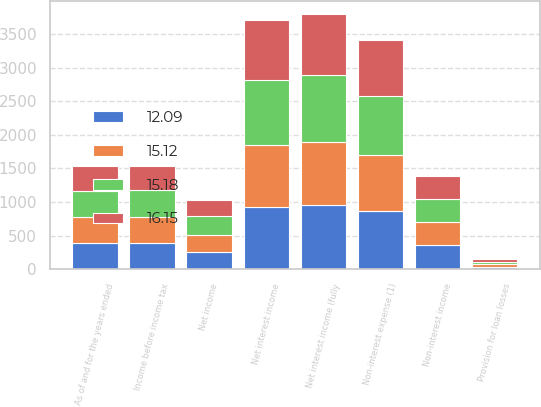Convert chart. <chart><loc_0><loc_0><loc_500><loc_500><stacked_bar_chart><ecel><fcel>As of and for the years ended<fcel>Net interest income (fully<fcel>Net interest income<fcel>Provision for loan losses<fcel>Non-interest income<fcel>Non-interest expense (1)<fcel>Income before income tax<fcel>Net income<nl><fcel>15.18<fcel>385.55<fcel>1004.5<fcel>972.2<fcel>36.6<fcel>342.7<fcel>868.8<fcel>409.5<fcel>281<nl><fcel>12.09<fcel>385.55<fcel>957.3<fcel>932.1<fcel>33.4<fcel>352.4<fcel>860.6<fcel>390.5<fcel>260.1<nl><fcel>15.12<fcel>385.55<fcel>931.1<fcel>911.9<fcel>40.6<fcel>350.8<fcel>841.5<fcel>380.6<fcel>251.7<nl><fcel>16.15<fcel>385.55<fcel>905.8<fcel>888.6<fcel>43.7<fcel>341.7<fcel>839<fcel>347.6<fcel>232.4<nl></chart> 